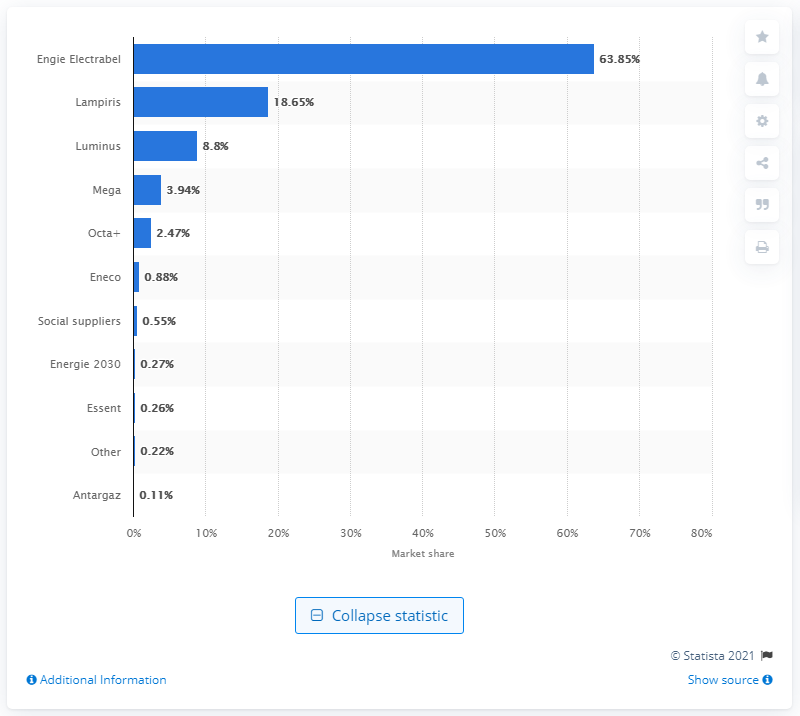Give some essential details in this illustration. In 2020, Lampiris was the second-largest supplier of electricity in the Brussels-Capital Region. 